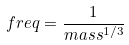<formula> <loc_0><loc_0><loc_500><loc_500>f r e q = \frac { 1 } { m a s s ^ { 1 / 3 } }</formula> 